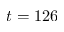Convert formula to latex. <formula><loc_0><loc_0><loc_500><loc_500>t = 1 2 6</formula> 